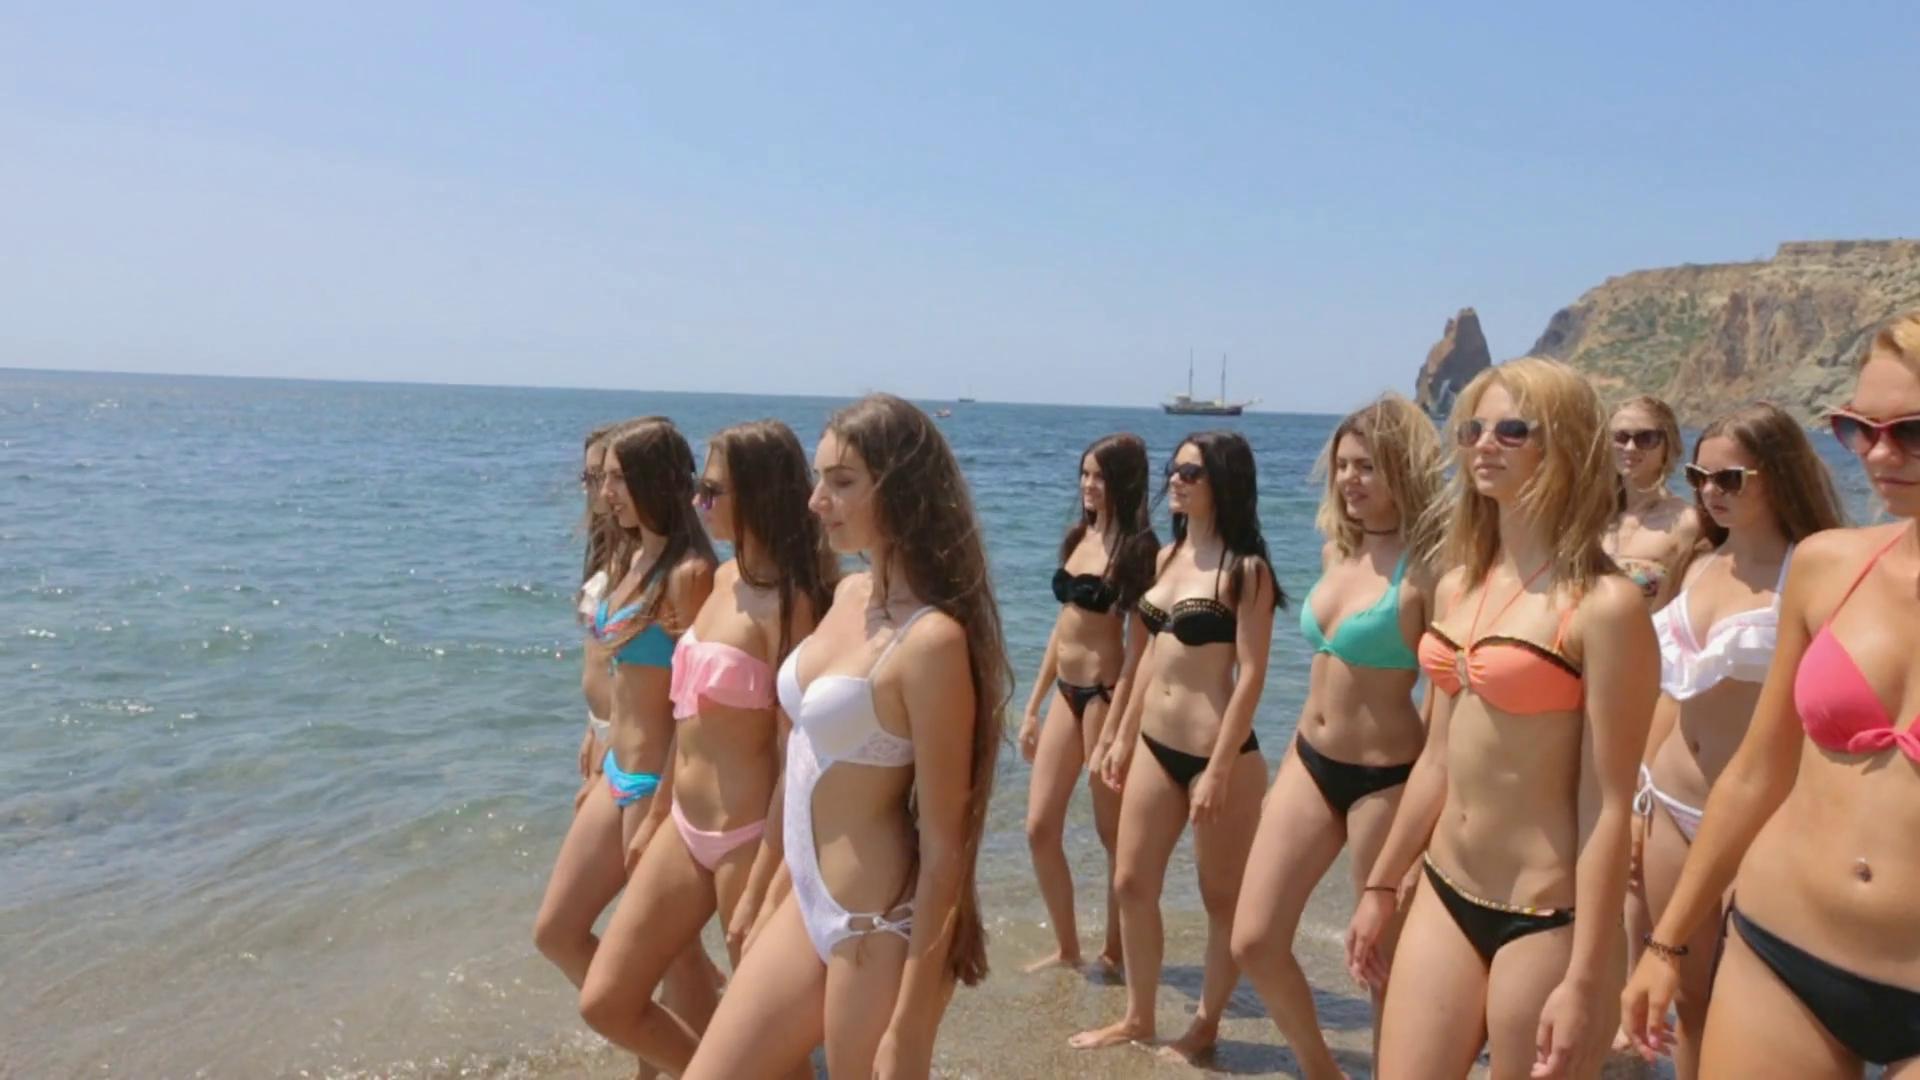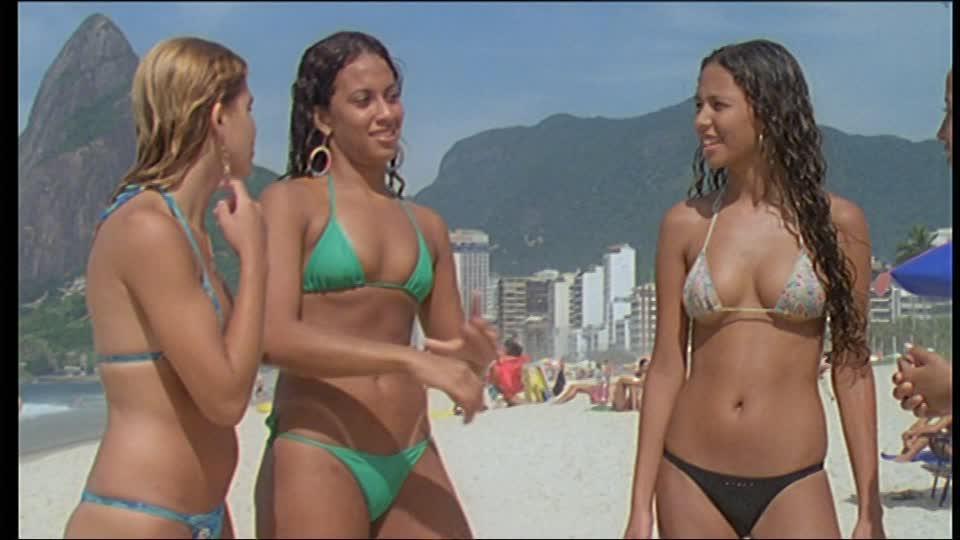The first image is the image on the left, the second image is the image on the right. For the images displayed, is the sentence "All bikini models are standing up and have their bodies facing the front." factually correct? Answer yes or no. No. The first image is the image on the left, the second image is the image on the right. Given the left and right images, does the statement "One of the images is focused on three girls wearing bikinis." hold true? Answer yes or no. Yes. 